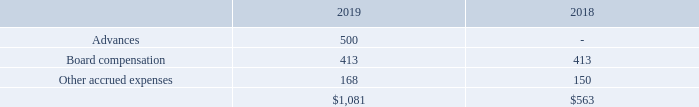7. ACCRUED LIABILITIES
Other accrued expenses consisted of the following at December 31, 2019 and 2018 (in thousands):
Advances are amounts received from litigation counsel as advanced reimbursement of out-of-pocket expenses expected to be incurred by us. Board compensation of $0.4 million at December 31, 2019 and 2018 represents accrued and unpaid board and committee fees from prior periods. In the first quarter of 2020, current and prior board members agreed to waive unpaid cash fees in exchange for share-based compensation awards with an aggregate grant-date fair value of approximately $0.1 million (see Note 18).
What is note 7 about? Accrued liabilities. Which years information is included in this note? 2018, 2019. What are advances? Advances are amounts received from litigation counsel as advanced reimbursement of out-of-pocket expenses expected to be incurred by us. How many categories of accrued liabilities are there? Advances##Board Compensation##Other accrued expenses
Answer: 3. Which is the largest category (in amount) in 2019? 500 > 413 > 168
Answer: advances. What is the total amount of the top 2 categories of accrued liabilities in 2019?
Answer scale should be: thousand. 500 + 413
Answer: 913. 